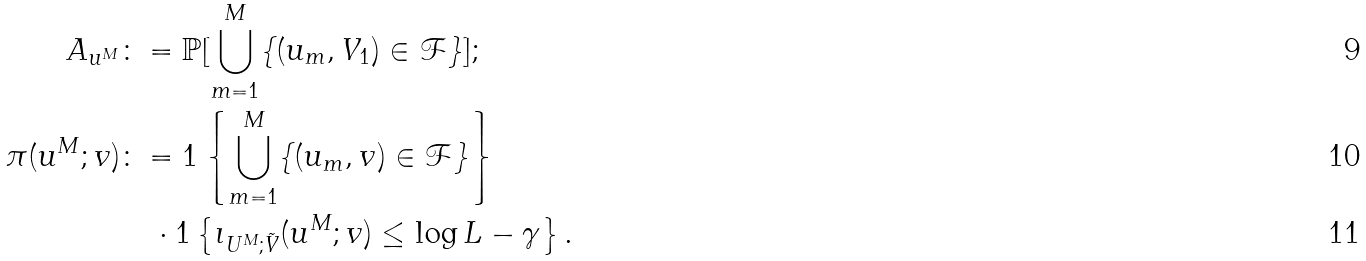<formula> <loc_0><loc_0><loc_500><loc_500>A _ { u ^ { M } } & \colon = \mathbb { P } [ \bigcup _ { m = 1 } ^ { M } \{ ( u _ { m } , V _ { 1 } ) \in \mathcal { F } \} ] ; \\ \pi ( u ^ { M } ; v ) & \colon = 1 \left \{ \bigcup _ { m = 1 } ^ { M } \{ ( u _ { m } , v ) \in \mathcal { F } \} \right \} \\ & \quad \cdot 1 \left \{ \imath _ { U ^ { M } ; \tilde { V } } ( u ^ { M } ; v ) \leq \log L - \gamma \right \} .</formula> 